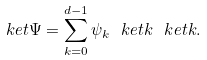<formula> <loc_0><loc_0><loc_500><loc_500>\ k e t { \Psi } = \sum _ { k = 0 } ^ { d - 1 } \psi _ { k } \ k e t k \ k e t k .</formula> 